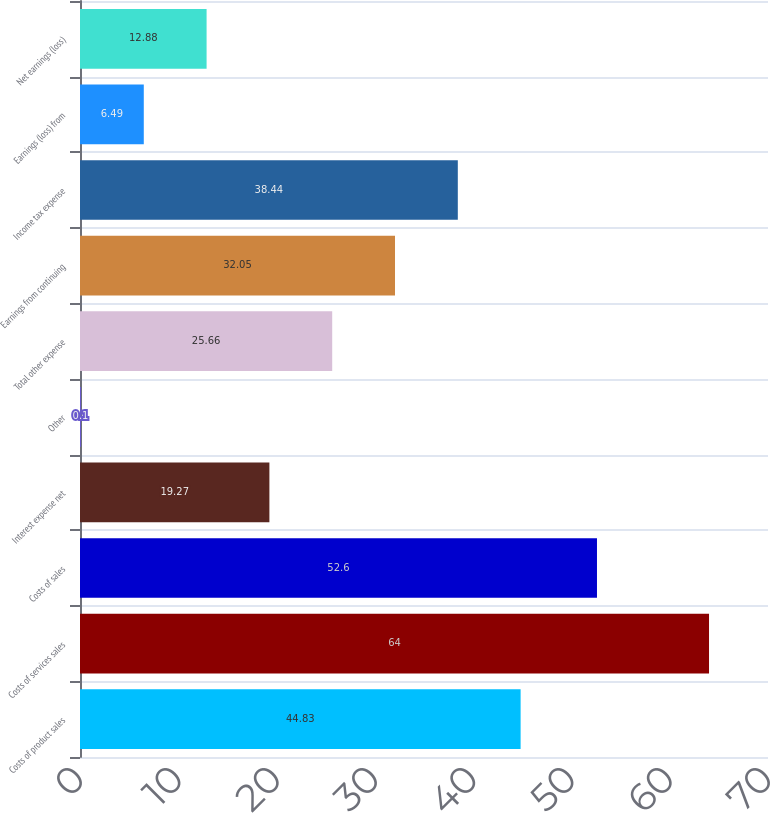<chart> <loc_0><loc_0><loc_500><loc_500><bar_chart><fcel>Costs of product sales<fcel>Costs of services sales<fcel>Costs of sales<fcel>Interest expense net<fcel>Other<fcel>Total other expense<fcel>Earnings from continuing<fcel>Income tax expense<fcel>Earnings (loss) from<fcel>Net earnings (loss)<nl><fcel>44.83<fcel>64<fcel>52.6<fcel>19.27<fcel>0.1<fcel>25.66<fcel>32.05<fcel>38.44<fcel>6.49<fcel>12.88<nl></chart> 